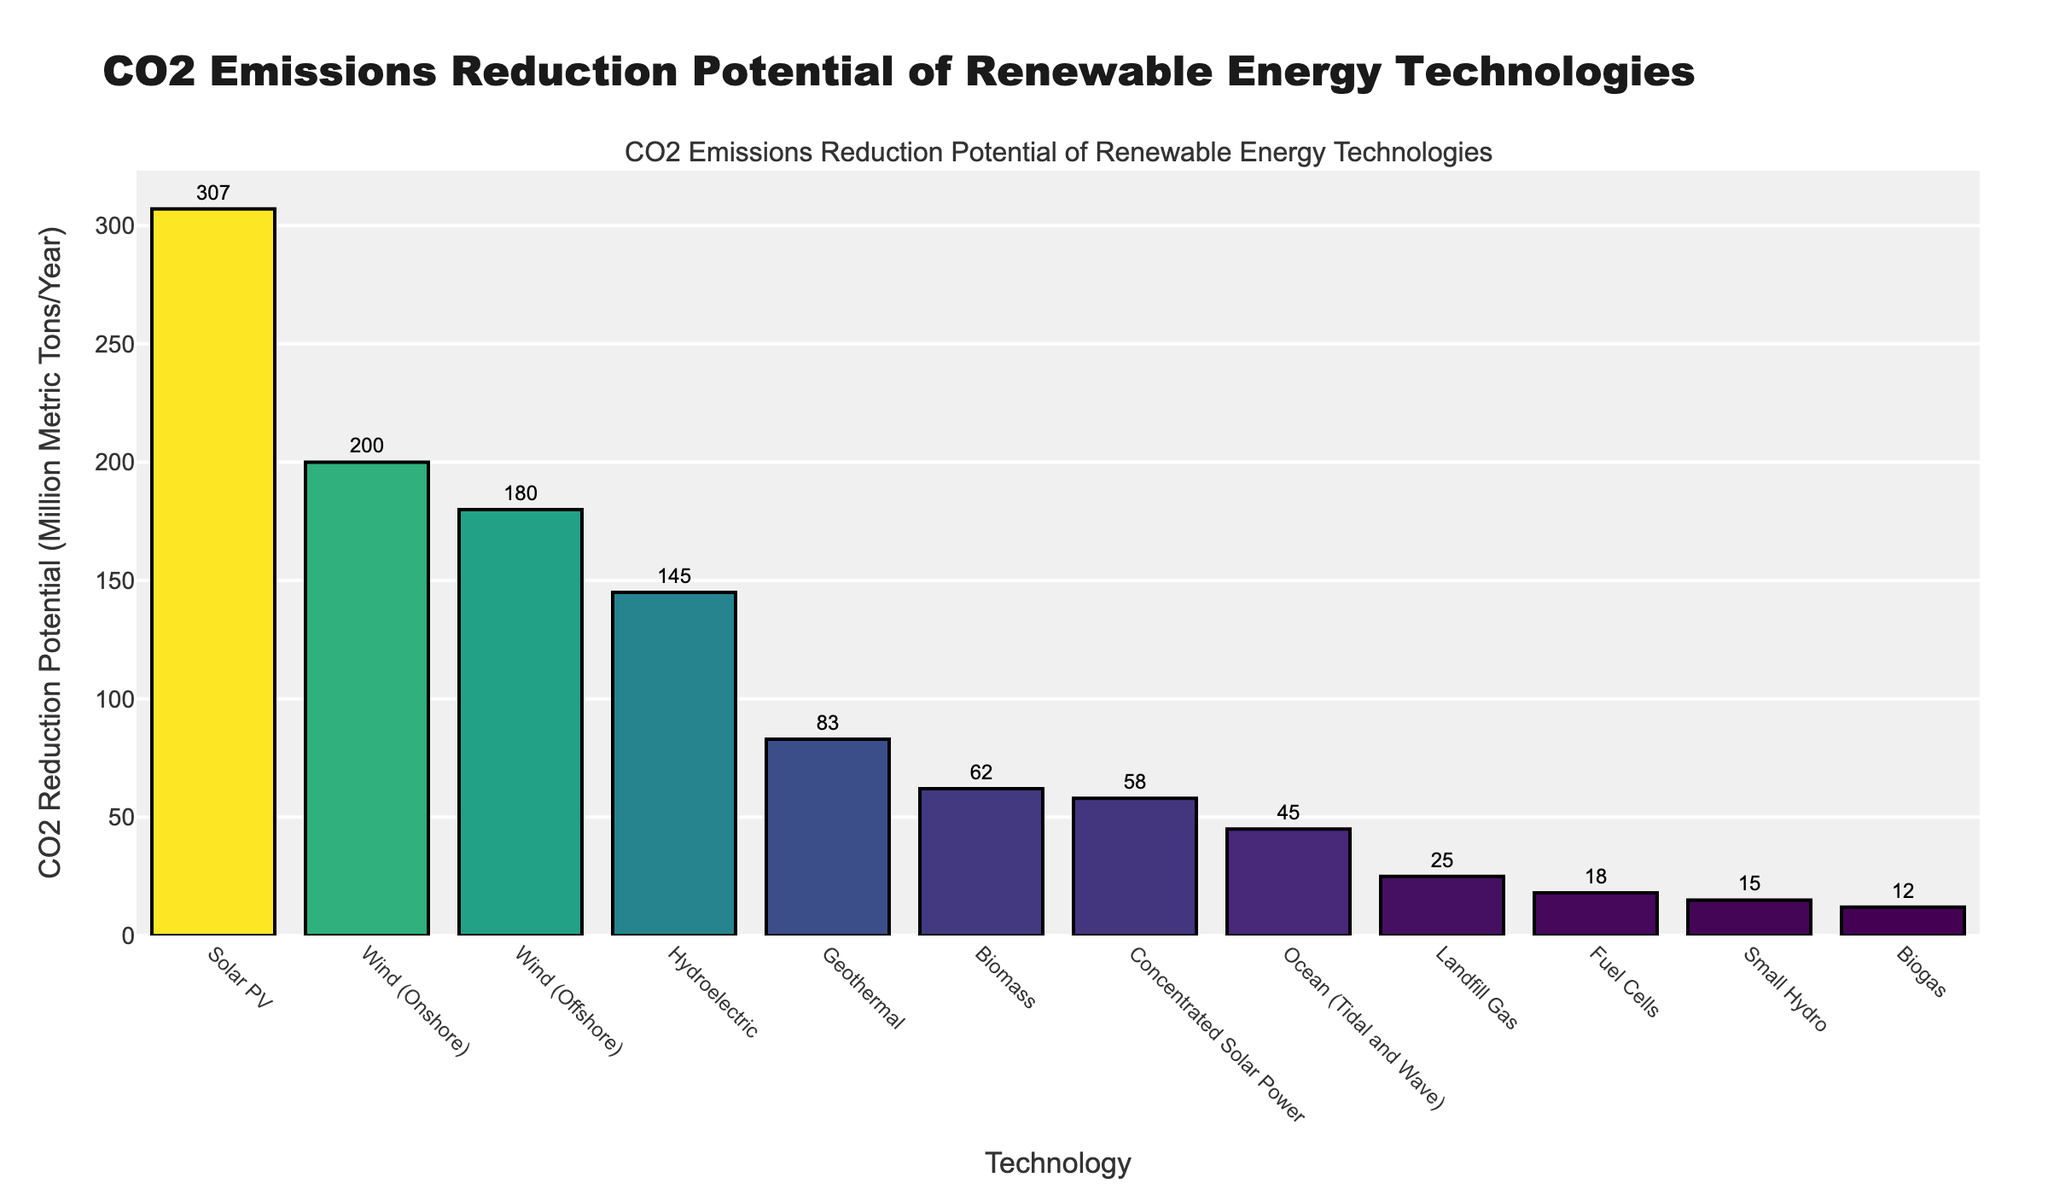What's the renewable energy technology with the highest CO2 reduction potential? The bar representing "Solar PV" is the tallest, indicating it has the highest CO2 reduction potential.
Answer: Solar PV How much higher is the CO2 reduction potential for Solar PV compared to Geothermal? The CO2 reduction potential for Solar PV is 307 and for Geothermal is 83. Subtracting 83 from 307 gives 224.
Answer: 224 Million Metric Tons/Year Which technology has a CO2 reduction potential close to 200 Million Metric Tons/Year? The bar for "Wind (Onshore)" closely matches the 200 million metric tons/year mark.
Answer: Wind (Onshore) What's the total CO2 reduction potential for Wind (Onshore) and Wind (Offshore)? The CO2 reduction potential for Wind (Onshore) is 200 and Wind (Offshore) is 180. Adding these together gives 380.
Answer: 380 Million Metric Tons/Year How does the CO2 reduction potential of Biomass compare to that of Geothermal? The bar for "Geothermal" is taller than that for "Biomass". Geothermal has a reduction potential of 83 while Biomass has 62.
Answer: Geothermal is higher What is the cumulative CO2 reduction potential of the top three technologies? The top three technologies are Solar PV (307), Wind (Onshore) (200), and Wind (Offshore) (180). Summing them gives 307 + 200 + 180 = 687.
Answer: 687 Million Metric Tons/Year Which technology has the least CO2 reduction potential? The shortest bar represents "Biogas" with the lowest value.
Answer: Biogas What’s the difference in CO2 reduction potential between the second and the third highest technologies? The CO2 reduction potential for Wind (Onshore) is 200 and for Wind (Offshore) is 180. Subtracting 180 from 200 gives 20.
Answer: 20 Million Metric Tons/Year If we combine Hydroelectric and Small Hydro, what would their combined CO2 reduction potential be? The CO2 reduction potential for Hydroelectric is 145 and for Small Hydro is 15. Adding these together gives 145 + 15 = 160.
Answer: 160 Million Metric Tons/Year What is the visual characteristic that distinguishes the technology with the highest CO2 reduction potential? The tallest bar, which also has the darkest color within the colorscale used.
Answer: Tallest and darkest bar 